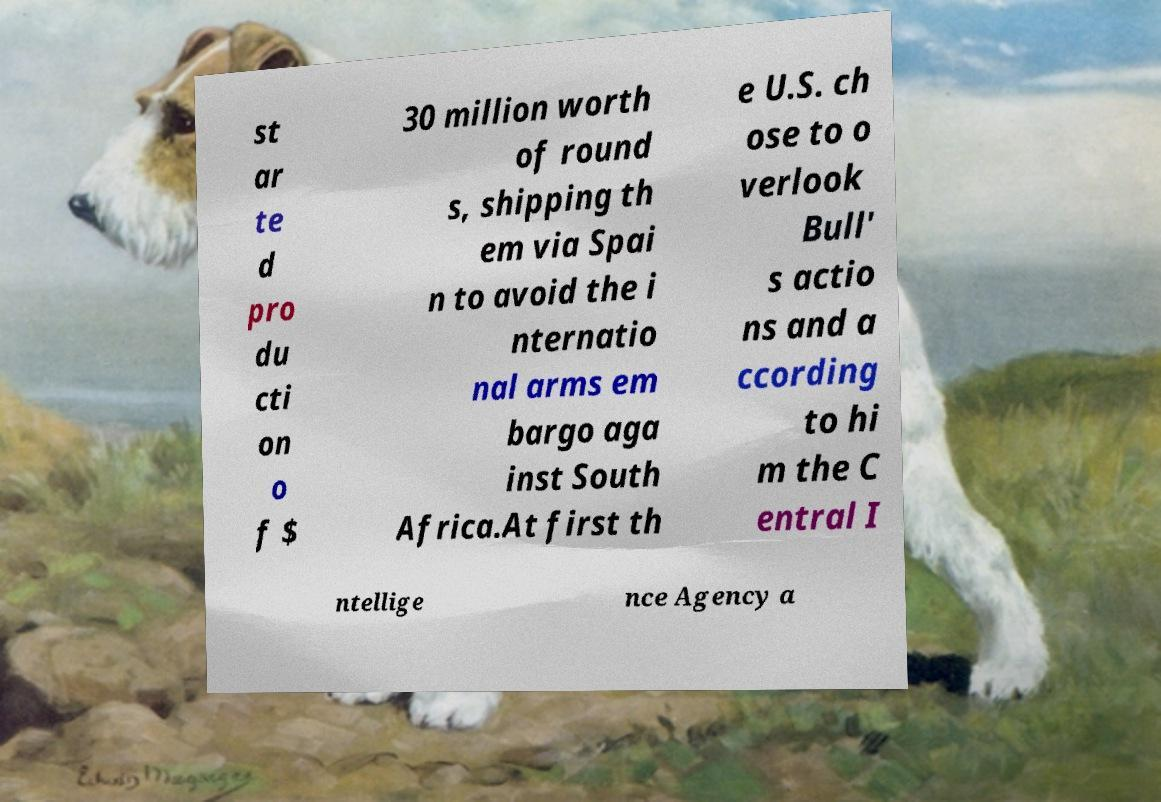For documentation purposes, I need the text within this image transcribed. Could you provide that? st ar te d pro du cti on o f $ 30 million worth of round s, shipping th em via Spai n to avoid the i nternatio nal arms em bargo aga inst South Africa.At first th e U.S. ch ose to o verlook Bull' s actio ns and a ccording to hi m the C entral I ntellige nce Agency a 